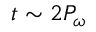Convert formula to latex. <formula><loc_0><loc_0><loc_500><loc_500>t \sim 2 P _ { \omega }</formula> 